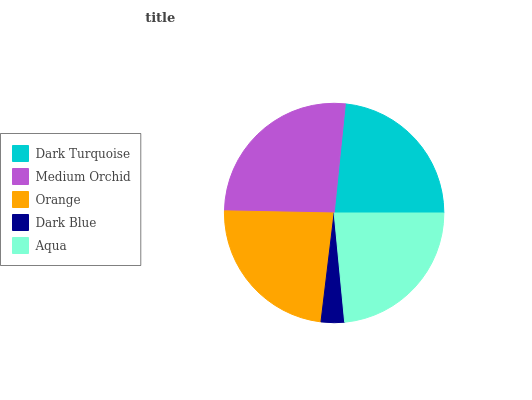Is Dark Blue the minimum?
Answer yes or no. Yes. Is Medium Orchid the maximum?
Answer yes or no. Yes. Is Orange the minimum?
Answer yes or no. No. Is Orange the maximum?
Answer yes or no. No. Is Medium Orchid greater than Orange?
Answer yes or no. Yes. Is Orange less than Medium Orchid?
Answer yes or no. Yes. Is Orange greater than Medium Orchid?
Answer yes or no. No. Is Medium Orchid less than Orange?
Answer yes or no. No. Is Orange the high median?
Answer yes or no. Yes. Is Orange the low median?
Answer yes or no. Yes. Is Aqua the high median?
Answer yes or no. No. Is Dark Turquoise the low median?
Answer yes or no. No. 